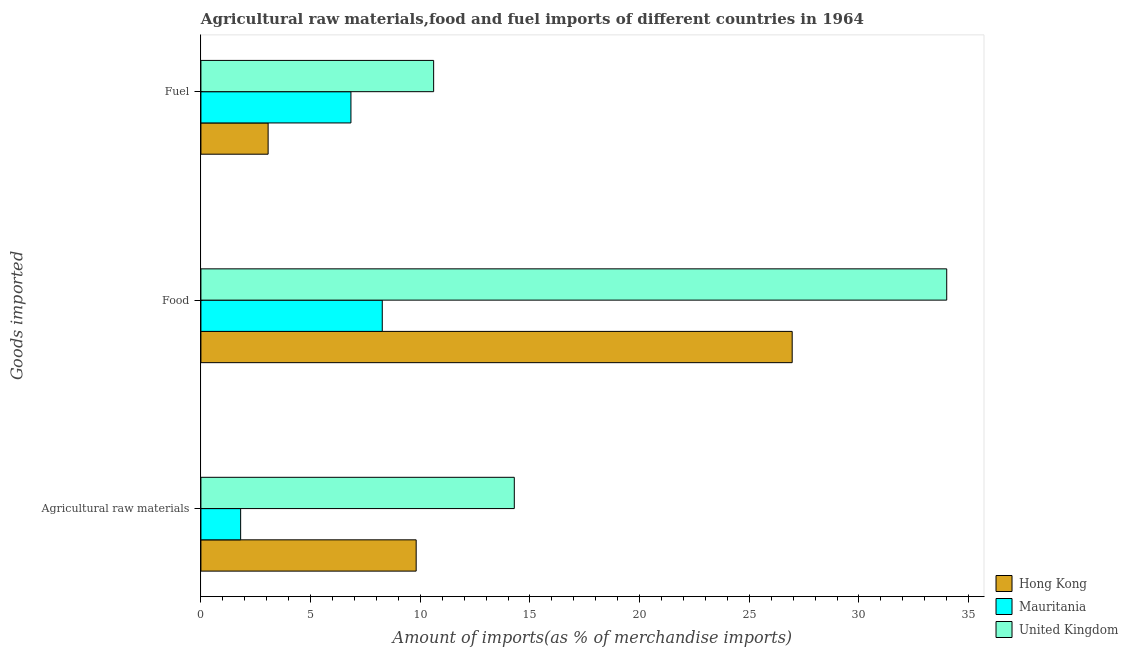How many different coloured bars are there?
Provide a succinct answer. 3. How many groups of bars are there?
Your answer should be very brief. 3. How many bars are there on the 1st tick from the bottom?
Provide a succinct answer. 3. What is the label of the 2nd group of bars from the top?
Offer a very short reply. Food. What is the percentage of raw materials imports in Mauritania?
Keep it short and to the point. 1.81. Across all countries, what is the maximum percentage of fuel imports?
Your answer should be compact. 10.61. Across all countries, what is the minimum percentage of food imports?
Your answer should be compact. 8.27. In which country was the percentage of food imports maximum?
Keep it short and to the point. United Kingdom. In which country was the percentage of food imports minimum?
Give a very brief answer. Mauritania. What is the total percentage of fuel imports in the graph?
Your answer should be compact. 20.51. What is the difference between the percentage of fuel imports in Hong Kong and that in Mauritania?
Offer a terse response. -3.78. What is the difference between the percentage of raw materials imports in United Kingdom and the percentage of food imports in Hong Kong?
Your response must be concise. -12.67. What is the average percentage of food imports per country?
Give a very brief answer. 23.07. What is the difference between the percentage of raw materials imports and percentage of food imports in United Kingdom?
Make the answer very short. -19.71. What is the ratio of the percentage of food imports in Mauritania to that in Hong Kong?
Ensure brevity in your answer.  0.31. What is the difference between the highest and the second highest percentage of raw materials imports?
Provide a short and direct response. 4.47. What is the difference between the highest and the lowest percentage of fuel imports?
Provide a succinct answer. 7.55. What does the 1st bar from the bottom in Food represents?
Make the answer very short. Hong Kong. Is it the case that in every country, the sum of the percentage of raw materials imports and percentage of food imports is greater than the percentage of fuel imports?
Keep it short and to the point. Yes. Are all the bars in the graph horizontal?
Give a very brief answer. Yes. What is the difference between two consecutive major ticks on the X-axis?
Your answer should be very brief. 5. How many legend labels are there?
Offer a very short reply. 3. How are the legend labels stacked?
Ensure brevity in your answer.  Vertical. What is the title of the graph?
Your answer should be very brief. Agricultural raw materials,food and fuel imports of different countries in 1964. What is the label or title of the X-axis?
Provide a short and direct response. Amount of imports(as % of merchandise imports). What is the label or title of the Y-axis?
Keep it short and to the point. Goods imported. What is the Amount of imports(as % of merchandise imports) in Hong Kong in Agricultural raw materials?
Offer a terse response. 9.81. What is the Amount of imports(as % of merchandise imports) in Mauritania in Agricultural raw materials?
Your answer should be compact. 1.81. What is the Amount of imports(as % of merchandise imports) of United Kingdom in Agricultural raw materials?
Make the answer very short. 14.29. What is the Amount of imports(as % of merchandise imports) of Hong Kong in Food?
Provide a succinct answer. 26.96. What is the Amount of imports(as % of merchandise imports) of Mauritania in Food?
Offer a terse response. 8.27. What is the Amount of imports(as % of merchandise imports) of United Kingdom in Food?
Your answer should be very brief. 34. What is the Amount of imports(as % of merchandise imports) in Hong Kong in Fuel?
Give a very brief answer. 3.06. What is the Amount of imports(as % of merchandise imports) in Mauritania in Fuel?
Your answer should be very brief. 6.84. What is the Amount of imports(as % of merchandise imports) in United Kingdom in Fuel?
Provide a short and direct response. 10.61. Across all Goods imported, what is the maximum Amount of imports(as % of merchandise imports) of Hong Kong?
Provide a succinct answer. 26.96. Across all Goods imported, what is the maximum Amount of imports(as % of merchandise imports) in Mauritania?
Make the answer very short. 8.27. Across all Goods imported, what is the maximum Amount of imports(as % of merchandise imports) in United Kingdom?
Your answer should be very brief. 34. Across all Goods imported, what is the minimum Amount of imports(as % of merchandise imports) of Hong Kong?
Ensure brevity in your answer.  3.06. Across all Goods imported, what is the minimum Amount of imports(as % of merchandise imports) in Mauritania?
Give a very brief answer. 1.81. Across all Goods imported, what is the minimum Amount of imports(as % of merchandise imports) of United Kingdom?
Provide a short and direct response. 10.61. What is the total Amount of imports(as % of merchandise imports) in Hong Kong in the graph?
Your answer should be compact. 39.83. What is the total Amount of imports(as % of merchandise imports) of Mauritania in the graph?
Offer a very short reply. 16.92. What is the total Amount of imports(as % of merchandise imports) in United Kingdom in the graph?
Give a very brief answer. 58.9. What is the difference between the Amount of imports(as % of merchandise imports) of Hong Kong in Agricultural raw materials and that in Food?
Ensure brevity in your answer.  -17.14. What is the difference between the Amount of imports(as % of merchandise imports) of Mauritania in Agricultural raw materials and that in Food?
Provide a short and direct response. -6.46. What is the difference between the Amount of imports(as % of merchandise imports) in United Kingdom in Agricultural raw materials and that in Food?
Make the answer very short. -19.71. What is the difference between the Amount of imports(as % of merchandise imports) in Hong Kong in Agricultural raw materials and that in Fuel?
Offer a terse response. 6.75. What is the difference between the Amount of imports(as % of merchandise imports) in Mauritania in Agricultural raw materials and that in Fuel?
Offer a terse response. -5.03. What is the difference between the Amount of imports(as % of merchandise imports) in United Kingdom in Agricultural raw materials and that in Fuel?
Make the answer very short. 3.68. What is the difference between the Amount of imports(as % of merchandise imports) in Hong Kong in Food and that in Fuel?
Keep it short and to the point. 23.89. What is the difference between the Amount of imports(as % of merchandise imports) in Mauritania in Food and that in Fuel?
Your answer should be compact. 1.43. What is the difference between the Amount of imports(as % of merchandise imports) of United Kingdom in Food and that in Fuel?
Ensure brevity in your answer.  23.39. What is the difference between the Amount of imports(as % of merchandise imports) of Hong Kong in Agricultural raw materials and the Amount of imports(as % of merchandise imports) of Mauritania in Food?
Provide a short and direct response. 1.55. What is the difference between the Amount of imports(as % of merchandise imports) of Hong Kong in Agricultural raw materials and the Amount of imports(as % of merchandise imports) of United Kingdom in Food?
Provide a succinct answer. -24.19. What is the difference between the Amount of imports(as % of merchandise imports) in Mauritania in Agricultural raw materials and the Amount of imports(as % of merchandise imports) in United Kingdom in Food?
Offer a very short reply. -32.19. What is the difference between the Amount of imports(as % of merchandise imports) of Hong Kong in Agricultural raw materials and the Amount of imports(as % of merchandise imports) of Mauritania in Fuel?
Offer a terse response. 2.97. What is the difference between the Amount of imports(as % of merchandise imports) of Hong Kong in Agricultural raw materials and the Amount of imports(as % of merchandise imports) of United Kingdom in Fuel?
Offer a very short reply. -0.8. What is the difference between the Amount of imports(as % of merchandise imports) of Mauritania in Agricultural raw materials and the Amount of imports(as % of merchandise imports) of United Kingdom in Fuel?
Keep it short and to the point. -8.8. What is the difference between the Amount of imports(as % of merchandise imports) of Hong Kong in Food and the Amount of imports(as % of merchandise imports) of Mauritania in Fuel?
Offer a terse response. 20.12. What is the difference between the Amount of imports(as % of merchandise imports) in Hong Kong in Food and the Amount of imports(as % of merchandise imports) in United Kingdom in Fuel?
Ensure brevity in your answer.  16.35. What is the difference between the Amount of imports(as % of merchandise imports) of Mauritania in Food and the Amount of imports(as % of merchandise imports) of United Kingdom in Fuel?
Your answer should be very brief. -2.34. What is the average Amount of imports(as % of merchandise imports) of Hong Kong per Goods imported?
Your answer should be very brief. 13.28. What is the average Amount of imports(as % of merchandise imports) of Mauritania per Goods imported?
Offer a terse response. 5.64. What is the average Amount of imports(as % of merchandise imports) of United Kingdom per Goods imported?
Your answer should be very brief. 19.63. What is the difference between the Amount of imports(as % of merchandise imports) of Hong Kong and Amount of imports(as % of merchandise imports) of Mauritania in Agricultural raw materials?
Ensure brevity in your answer.  8. What is the difference between the Amount of imports(as % of merchandise imports) in Hong Kong and Amount of imports(as % of merchandise imports) in United Kingdom in Agricultural raw materials?
Offer a very short reply. -4.47. What is the difference between the Amount of imports(as % of merchandise imports) of Mauritania and Amount of imports(as % of merchandise imports) of United Kingdom in Agricultural raw materials?
Your answer should be very brief. -12.48. What is the difference between the Amount of imports(as % of merchandise imports) of Hong Kong and Amount of imports(as % of merchandise imports) of Mauritania in Food?
Make the answer very short. 18.69. What is the difference between the Amount of imports(as % of merchandise imports) of Hong Kong and Amount of imports(as % of merchandise imports) of United Kingdom in Food?
Your answer should be very brief. -7.05. What is the difference between the Amount of imports(as % of merchandise imports) in Mauritania and Amount of imports(as % of merchandise imports) in United Kingdom in Food?
Your answer should be very brief. -25.73. What is the difference between the Amount of imports(as % of merchandise imports) of Hong Kong and Amount of imports(as % of merchandise imports) of Mauritania in Fuel?
Your response must be concise. -3.78. What is the difference between the Amount of imports(as % of merchandise imports) in Hong Kong and Amount of imports(as % of merchandise imports) in United Kingdom in Fuel?
Make the answer very short. -7.55. What is the difference between the Amount of imports(as % of merchandise imports) in Mauritania and Amount of imports(as % of merchandise imports) in United Kingdom in Fuel?
Give a very brief answer. -3.77. What is the ratio of the Amount of imports(as % of merchandise imports) of Hong Kong in Agricultural raw materials to that in Food?
Your answer should be very brief. 0.36. What is the ratio of the Amount of imports(as % of merchandise imports) of Mauritania in Agricultural raw materials to that in Food?
Provide a succinct answer. 0.22. What is the ratio of the Amount of imports(as % of merchandise imports) of United Kingdom in Agricultural raw materials to that in Food?
Keep it short and to the point. 0.42. What is the ratio of the Amount of imports(as % of merchandise imports) in Hong Kong in Agricultural raw materials to that in Fuel?
Offer a terse response. 3.2. What is the ratio of the Amount of imports(as % of merchandise imports) of Mauritania in Agricultural raw materials to that in Fuel?
Keep it short and to the point. 0.26. What is the ratio of the Amount of imports(as % of merchandise imports) of United Kingdom in Agricultural raw materials to that in Fuel?
Provide a succinct answer. 1.35. What is the ratio of the Amount of imports(as % of merchandise imports) of Hong Kong in Food to that in Fuel?
Your answer should be very brief. 8.8. What is the ratio of the Amount of imports(as % of merchandise imports) of Mauritania in Food to that in Fuel?
Provide a short and direct response. 1.21. What is the ratio of the Amount of imports(as % of merchandise imports) in United Kingdom in Food to that in Fuel?
Offer a terse response. 3.2. What is the difference between the highest and the second highest Amount of imports(as % of merchandise imports) of Hong Kong?
Offer a terse response. 17.14. What is the difference between the highest and the second highest Amount of imports(as % of merchandise imports) in Mauritania?
Your response must be concise. 1.43. What is the difference between the highest and the second highest Amount of imports(as % of merchandise imports) of United Kingdom?
Offer a very short reply. 19.71. What is the difference between the highest and the lowest Amount of imports(as % of merchandise imports) in Hong Kong?
Your answer should be very brief. 23.89. What is the difference between the highest and the lowest Amount of imports(as % of merchandise imports) in Mauritania?
Offer a terse response. 6.46. What is the difference between the highest and the lowest Amount of imports(as % of merchandise imports) in United Kingdom?
Give a very brief answer. 23.39. 